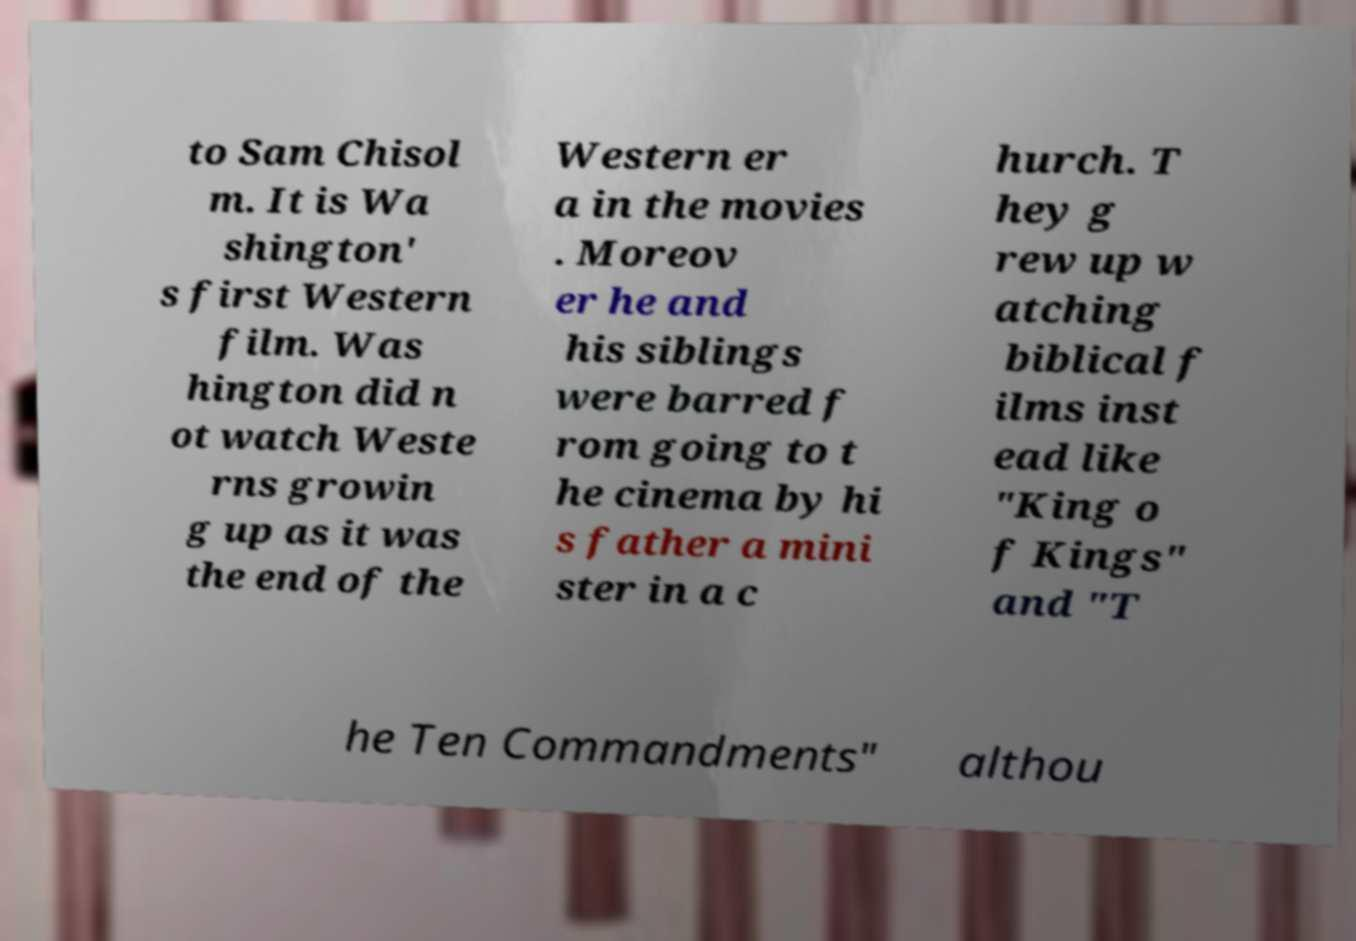Can you read and provide the text displayed in the image?This photo seems to have some interesting text. Can you extract and type it out for me? to Sam Chisol m. It is Wa shington' s first Western film. Was hington did n ot watch Weste rns growin g up as it was the end of the Western er a in the movies . Moreov er he and his siblings were barred f rom going to t he cinema by hi s father a mini ster in a c hurch. T hey g rew up w atching biblical f ilms inst ead like "King o f Kings" and "T he Ten Commandments" althou 